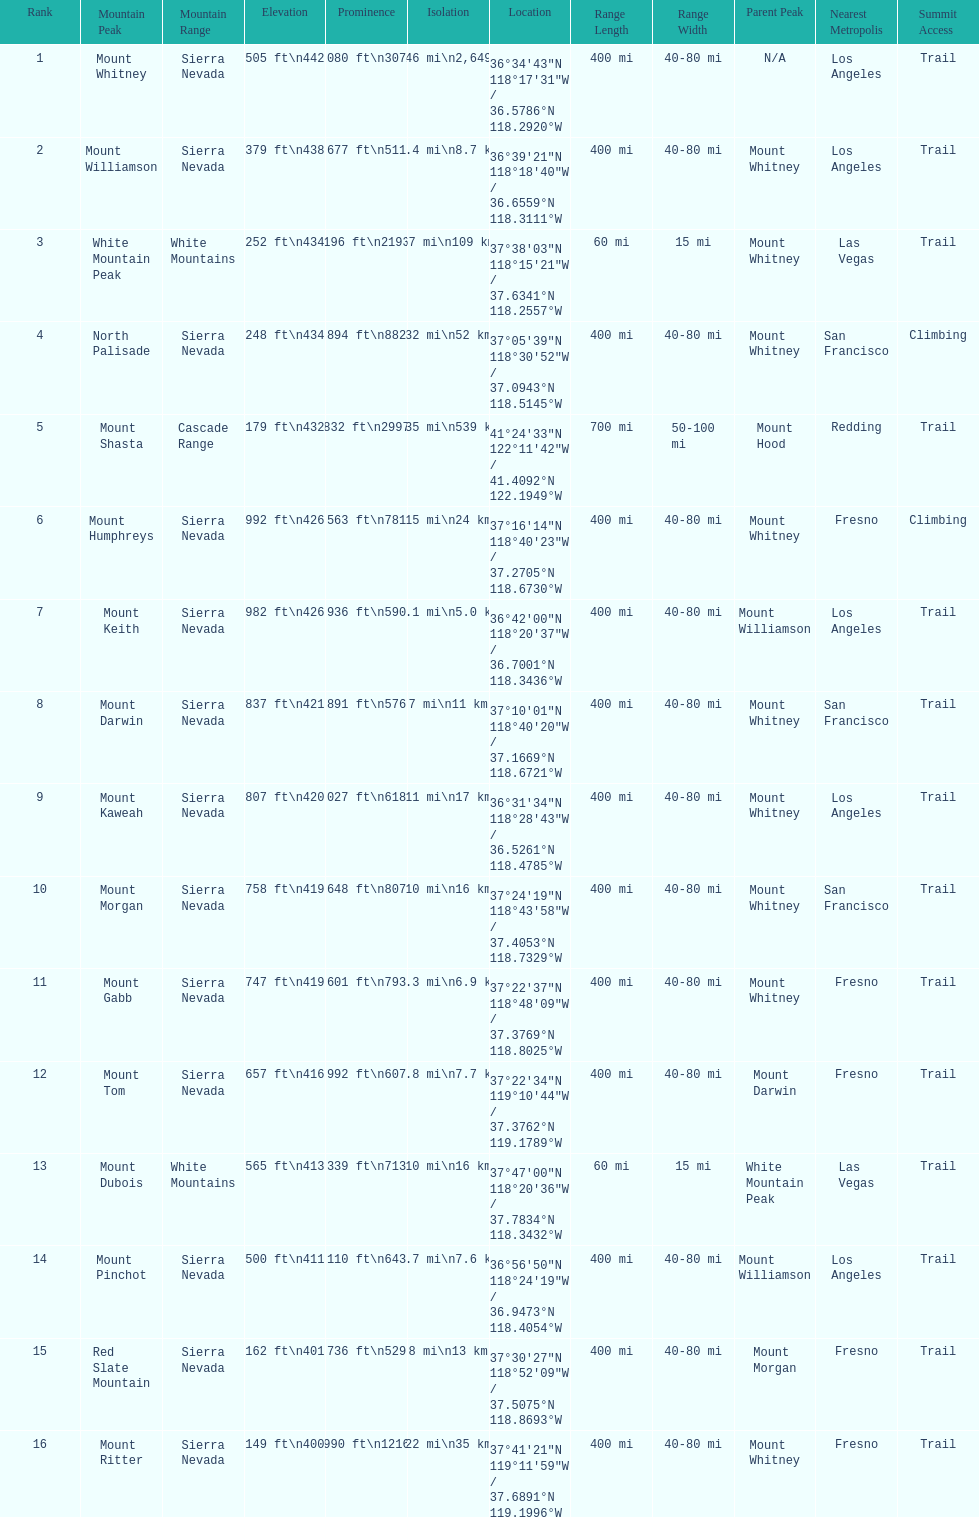Which mountain peak has the least isolation? Mount Keith. 